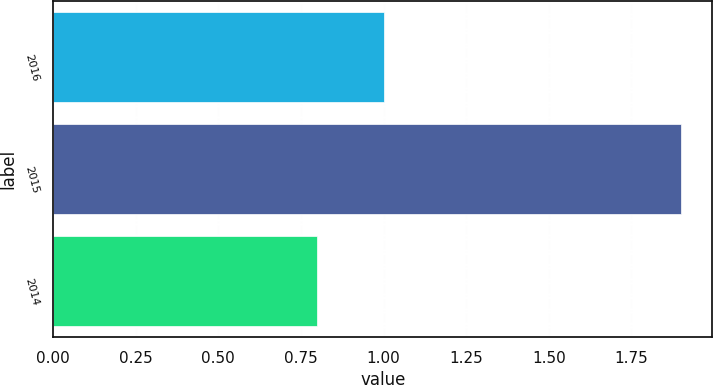Convert chart. <chart><loc_0><loc_0><loc_500><loc_500><bar_chart><fcel>2016<fcel>2015<fcel>2014<nl><fcel>1<fcel>1.9<fcel>0.8<nl></chart> 